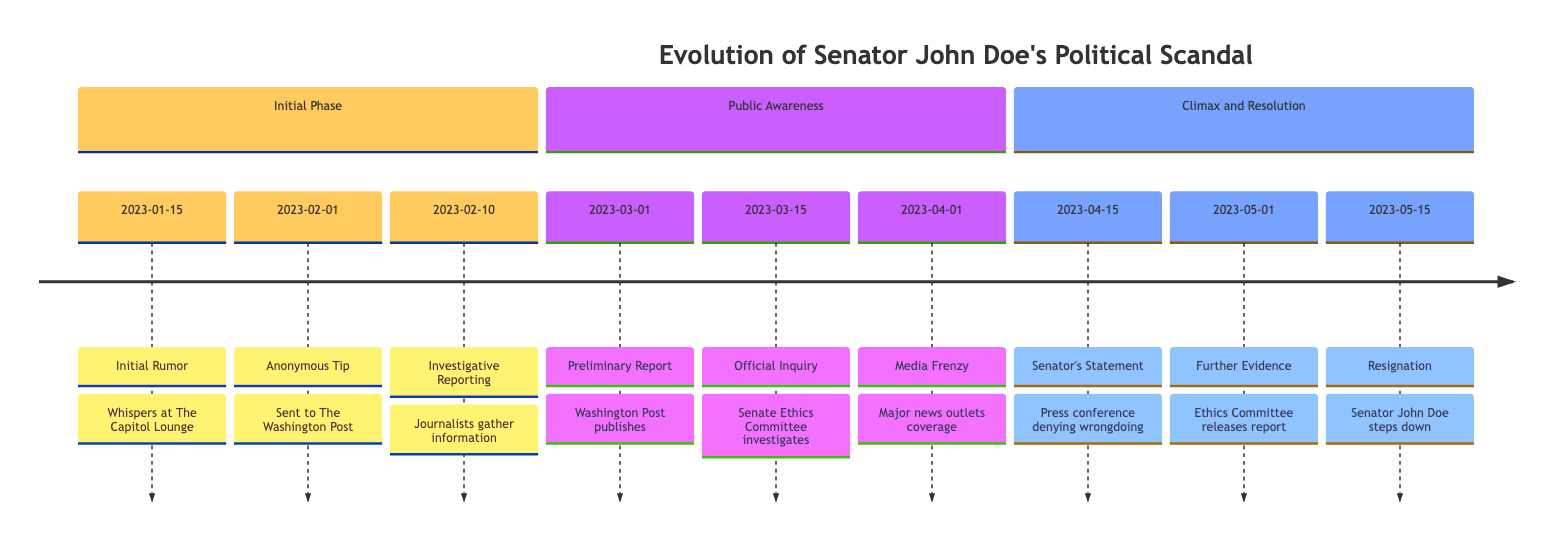What is the initial date of the timeline? The timeline begins with the first event on January 15, 2023, which is labeled as "Initial Rumor." This is the earliest date mentioned in the timeline.
Answer: 2023-01-15 How many events are listed in the timeline? By counting through the events presented in the timeline, we see there are a total of nine distinct events. This count includes all entries from the "Initial Phase," "Public Awareness," and "Climax and Resolution."
Answer: 9 What significant event occurred on March 15, 2023? On this date, the timeline highlights the "Official Inquiry" where the Senate Ethics Committee announces it will investigate the allegations. This is a key milestone in the timeline of the scandal.
Answer: Official Inquiry What was the outcome of the timeline on May 15, 2023? The last event listed is "Resignation," indicating that Senator John Doe announced his resignation on this date. This marks the conclusion of the scandal's timeline.
Answer: Resignation Which media outlet began investigating the claims on February 10, 2023? The event labeled "Investigative Reporting" indicates that journalists from The Washington Post started to investigate the claims on this date. This shows the involvement of an important media player.
Answer: The Washington Post What event correlates with the date March 01, 2023? This date corresponds to the "Preliminary Report" published by The Washington Post, suggesting there were financial anomalies in Senator John Doe's campaign accounts. This event is pivotal for public awareness.
Answer: Preliminary Report On what date did Senator John Doe hold a press conference? The press conference occurred on April 15, 2023, where Senator John Doe made a statement denying wrongdoing but acknowledging irregularities, representing a critical moment for public scrutiny.
Answer: April 15, 2023 What is the first event that reflects media coverage? The event titled "Media Frenzy," occurring on April 1, 2023, is the first instance in the timeline where major news outlets cover the scandal extensively, indicating a surge in media interest.
Answer: Media Frenzy What kind of atmosphere was seen at The Capitol Lounge during the unfolding scandal? Throughout different events in the timeline, it is noted that bartenders at The Capitol Lounge observed an increase in patrons discussing the scandal, indicating a politically charged atmosphere at the venue.
Answer: Politically charged 